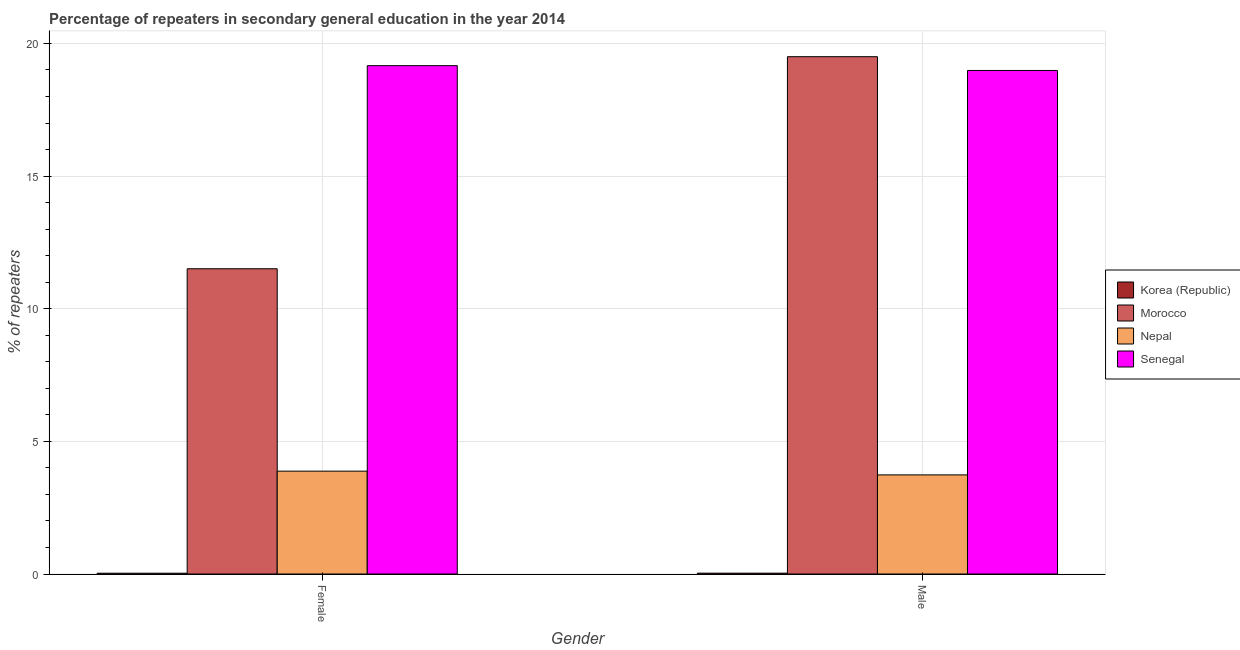Are the number of bars per tick equal to the number of legend labels?
Your answer should be very brief. Yes. How many bars are there on the 1st tick from the right?
Provide a succinct answer. 4. What is the percentage of male repeaters in Korea (Republic)?
Provide a short and direct response. 0.03. Across all countries, what is the maximum percentage of male repeaters?
Make the answer very short. 19.5. Across all countries, what is the minimum percentage of male repeaters?
Ensure brevity in your answer.  0.03. In which country was the percentage of male repeaters maximum?
Make the answer very short. Morocco. In which country was the percentage of male repeaters minimum?
Your answer should be compact. Korea (Republic). What is the total percentage of female repeaters in the graph?
Give a very brief answer. 34.58. What is the difference between the percentage of male repeaters in Korea (Republic) and that in Senegal?
Make the answer very short. -18.95. What is the difference between the percentage of female repeaters in Korea (Republic) and the percentage of male repeaters in Nepal?
Make the answer very short. -3.71. What is the average percentage of female repeaters per country?
Offer a very short reply. 8.64. What is the difference between the percentage of female repeaters and percentage of male repeaters in Senegal?
Provide a short and direct response. 0.18. What is the ratio of the percentage of male repeaters in Senegal to that in Nepal?
Provide a succinct answer. 5.08. What does the 2nd bar from the left in Male represents?
Make the answer very short. Morocco. Are the values on the major ticks of Y-axis written in scientific E-notation?
Keep it short and to the point. No. Does the graph contain grids?
Give a very brief answer. Yes. Where does the legend appear in the graph?
Offer a terse response. Center right. How many legend labels are there?
Keep it short and to the point. 4. What is the title of the graph?
Offer a very short reply. Percentage of repeaters in secondary general education in the year 2014. Does "Philippines" appear as one of the legend labels in the graph?
Make the answer very short. No. What is the label or title of the Y-axis?
Make the answer very short. % of repeaters. What is the % of repeaters of Korea (Republic) in Female?
Ensure brevity in your answer.  0.03. What is the % of repeaters of Morocco in Female?
Your response must be concise. 11.51. What is the % of repeaters in Nepal in Female?
Keep it short and to the point. 3.88. What is the % of repeaters in Senegal in Female?
Provide a short and direct response. 19.16. What is the % of repeaters of Korea (Republic) in Male?
Make the answer very short. 0.03. What is the % of repeaters in Morocco in Male?
Provide a succinct answer. 19.5. What is the % of repeaters in Nepal in Male?
Provide a short and direct response. 3.74. What is the % of repeaters of Senegal in Male?
Keep it short and to the point. 18.98. Across all Gender, what is the maximum % of repeaters in Korea (Republic)?
Your answer should be compact. 0.03. Across all Gender, what is the maximum % of repeaters of Morocco?
Provide a succinct answer. 19.5. Across all Gender, what is the maximum % of repeaters of Nepal?
Offer a terse response. 3.88. Across all Gender, what is the maximum % of repeaters in Senegal?
Give a very brief answer. 19.16. Across all Gender, what is the minimum % of repeaters of Korea (Republic)?
Make the answer very short. 0.03. Across all Gender, what is the minimum % of repeaters of Morocco?
Ensure brevity in your answer.  11.51. Across all Gender, what is the minimum % of repeaters in Nepal?
Your answer should be compact. 3.74. Across all Gender, what is the minimum % of repeaters of Senegal?
Provide a succinct answer. 18.98. What is the total % of repeaters of Korea (Republic) in the graph?
Keep it short and to the point. 0.06. What is the total % of repeaters in Morocco in the graph?
Keep it short and to the point. 31.01. What is the total % of repeaters of Nepal in the graph?
Give a very brief answer. 7.61. What is the total % of repeaters of Senegal in the graph?
Offer a terse response. 38.15. What is the difference between the % of repeaters of Korea (Republic) in Female and that in Male?
Give a very brief answer. -0. What is the difference between the % of repeaters in Morocco in Female and that in Male?
Make the answer very short. -7.99. What is the difference between the % of repeaters in Nepal in Female and that in Male?
Offer a very short reply. 0.14. What is the difference between the % of repeaters of Senegal in Female and that in Male?
Your response must be concise. 0.18. What is the difference between the % of repeaters of Korea (Republic) in Female and the % of repeaters of Morocco in Male?
Provide a succinct answer. -19.47. What is the difference between the % of repeaters of Korea (Republic) in Female and the % of repeaters of Nepal in Male?
Your answer should be compact. -3.71. What is the difference between the % of repeaters in Korea (Republic) in Female and the % of repeaters in Senegal in Male?
Your answer should be very brief. -18.95. What is the difference between the % of repeaters in Morocco in Female and the % of repeaters in Nepal in Male?
Offer a terse response. 7.77. What is the difference between the % of repeaters of Morocco in Female and the % of repeaters of Senegal in Male?
Offer a terse response. -7.47. What is the difference between the % of repeaters in Nepal in Female and the % of repeaters in Senegal in Male?
Provide a succinct answer. -15.1. What is the average % of repeaters of Korea (Republic) per Gender?
Give a very brief answer. 0.03. What is the average % of repeaters in Morocco per Gender?
Your answer should be very brief. 15.5. What is the average % of repeaters of Nepal per Gender?
Ensure brevity in your answer.  3.81. What is the average % of repeaters in Senegal per Gender?
Give a very brief answer. 19.07. What is the difference between the % of repeaters of Korea (Republic) and % of repeaters of Morocco in Female?
Your answer should be compact. -11.48. What is the difference between the % of repeaters of Korea (Republic) and % of repeaters of Nepal in Female?
Keep it short and to the point. -3.85. What is the difference between the % of repeaters of Korea (Republic) and % of repeaters of Senegal in Female?
Your answer should be compact. -19.13. What is the difference between the % of repeaters in Morocco and % of repeaters in Nepal in Female?
Offer a terse response. 7.63. What is the difference between the % of repeaters of Morocco and % of repeaters of Senegal in Female?
Your response must be concise. -7.66. What is the difference between the % of repeaters of Nepal and % of repeaters of Senegal in Female?
Ensure brevity in your answer.  -15.29. What is the difference between the % of repeaters in Korea (Republic) and % of repeaters in Morocco in Male?
Your response must be concise. -19.47. What is the difference between the % of repeaters of Korea (Republic) and % of repeaters of Nepal in Male?
Provide a short and direct response. -3.7. What is the difference between the % of repeaters of Korea (Republic) and % of repeaters of Senegal in Male?
Make the answer very short. -18.95. What is the difference between the % of repeaters in Morocco and % of repeaters in Nepal in Male?
Your response must be concise. 15.77. What is the difference between the % of repeaters of Morocco and % of repeaters of Senegal in Male?
Provide a succinct answer. 0.52. What is the difference between the % of repeaters in Nepal and % of repeaters in Senegal in Male?
Your answer should be compact. -15.25. What is the ratio of the % of repeaters of Korea (Republic) in Female to that in Male?
Keep it short and to the point. 0.93. What is the ratio of the % of repeaters of Morocco in Female to that in Male?
Make the answer very short. 0.59. What is the ratio of the % of repeaters of Nepal in Female to that in Male?
Your response must be concise. 1.04. What is the ratio of the % of repeaters in Senegal in Female to that in Male?
Provide a succinct answer. 1.01. What is the difference between the highest and the second highest % of repeaters in Korea (Republic)?
Give a very brief answer. 0. What is the difference between the highest and the second highest % of repeaters of Morocco?
Your response must be concise. 7.99. What is the difference between the highest and the second highest % of repeaters of Nepal?
Offer a very short reply. 0.14. What is the difference between the highest and the second highest % of repeaters in Senegal?
Your answer should be compact. 0.18. What is the difference between the highest and the lowest % of repeaters of Korea (Republic)?
Your response must be concise. 0. What is the difference between the highest and the lowest % of repeaters of Morocco?
Ensure brevity in your answer.  7.99. What is the difference between the highest and the lowest % of repeaters in Nepal?
Provide a short and direct response. 0.14. What is the difference between the highest and the lowest % of repeaters of Senegal?
Your answer should be very brief. 0.18. 